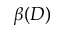<formula> <loc_0><loc_0><loc_500><loc_500>\beta ( D )</formula> 